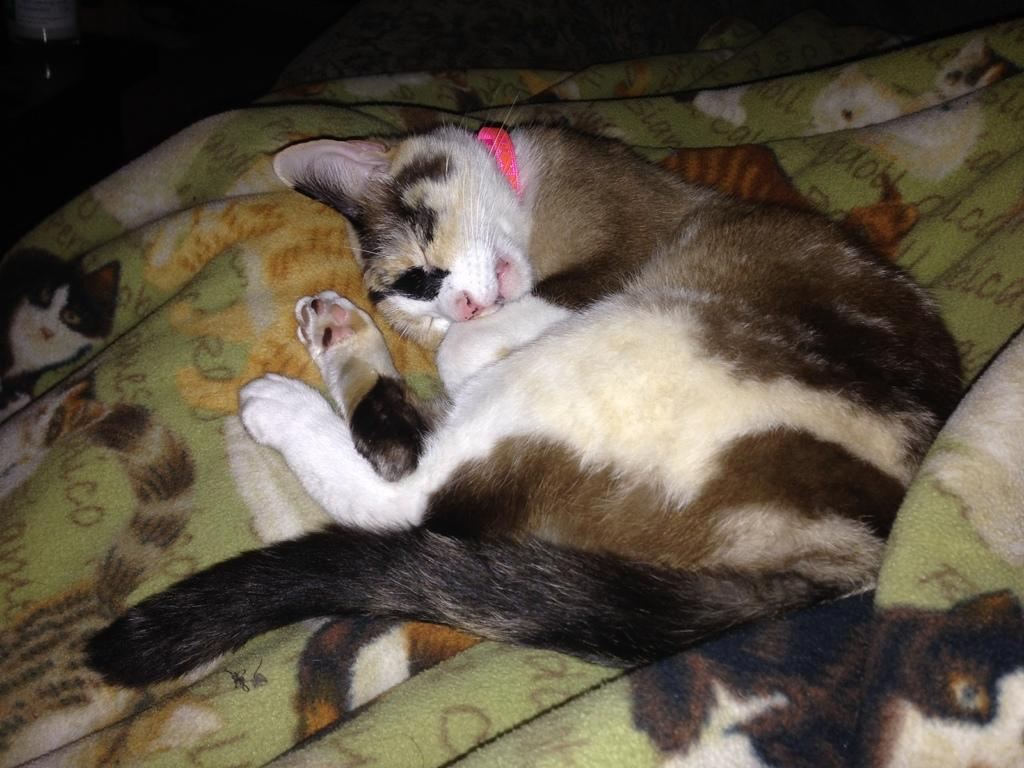What animal is present in the image? There is a cat in the image. What is the cat doing in the image? The cat is sleeping on a blanket. Can you describe any other objects in the background of the image? There is an object that looks like a bottle in the background of the image. What type of payment is being made by the minister in the image? There is no minister or payment present in the image; it features a cat sleeping on a blanket and a bottle-like object in the background. Can you describe the curve of the cat's tail in the image? The image does not show the cat's tail, so it is not possible to describe its curve. 